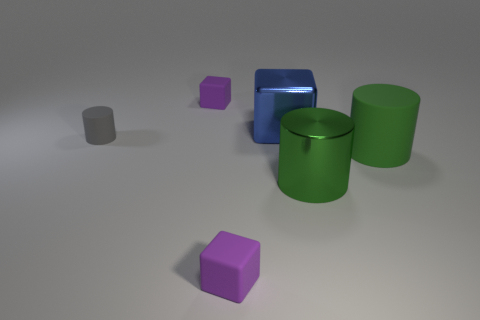Are there fewer small purple rubber objects behind the large blue thing than big green cylinders behind the gray cylinder?
Ensure brevity in your answer.  No. What color is the shiny cube?
Your answer should be compact. Blue. Is there a matte block of the same color as the small rubber cylinder?
Your answer should be very brief. No. What shape is the object to the left of the tiny purple rubber cube that is behind the large green matte object on the right side of the big green metallic cylinder?
Your response must be concise. Cylinder. There is a purple thing in front of the green rubber object; what is it made of?
Offer a terse response. Rubber. There is a cylinder left of the purple block that is in front of the green matte cylinder in front of the small cylinder; what size is it?
Make the answer very short. Small. Does the blue metal thing have the same size as the purple thing behind the large blue thing?
Make the answer very short. No. What color is the rubber object that is behind the blue metallic cube?
Provide a short and direct response. Purple. What is the shape of the other large object that is the same color as the large matte object?
Ensure brevity in your answer.  Cylinder. There is a big metal object that is in front of the gray thing; what shape is it?
Offer a terse response. Cylinder. 